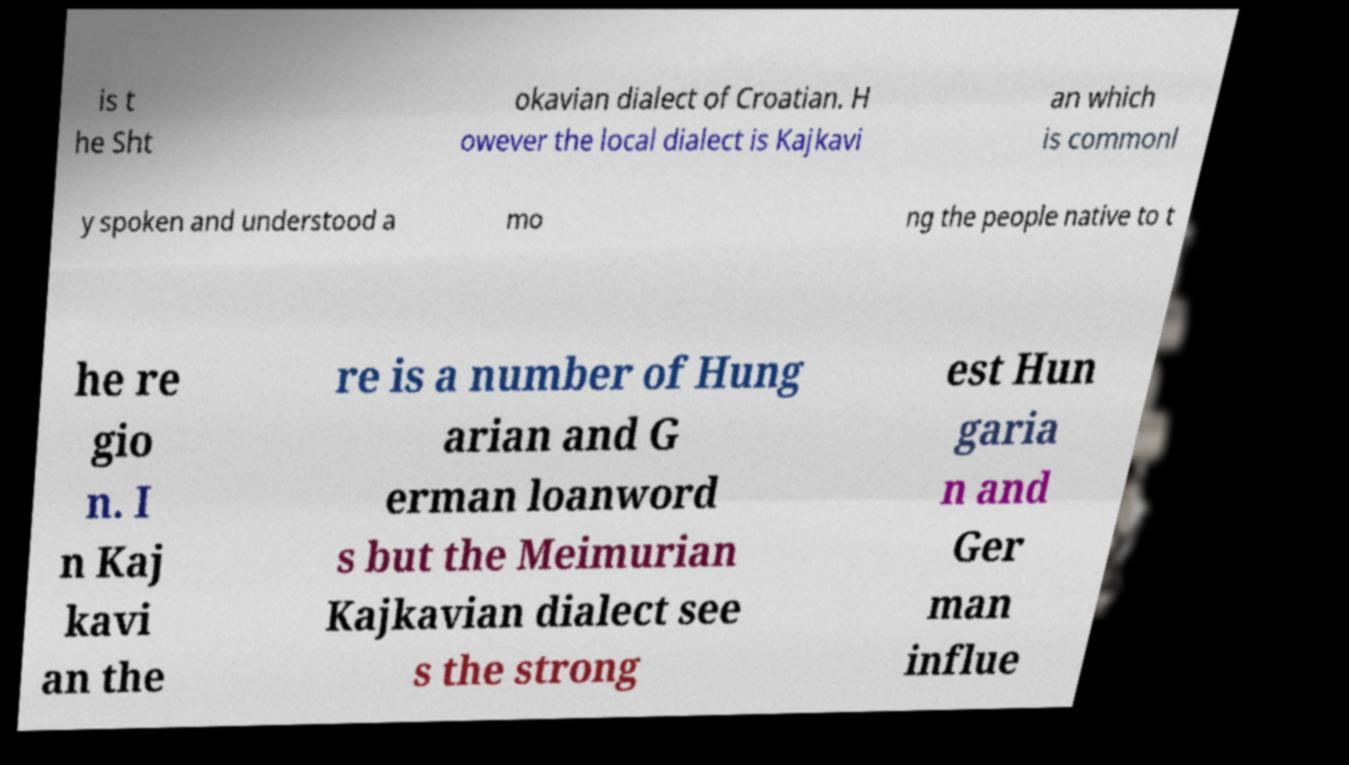Could you assist in decoding the text presented in this image and type it out clearly? is t he Sht okavian dialect of Croatian. H owever the local dialect is Kajkavi an which is commonl y spoken and understood a mo ng the people native to t he re gio n. I n Kaj kavi an the re is a number of Hung arian and G erman loanword s but the Meimurian Kajkavian dialect see s the strong est Hun garia n and Ger man influe 